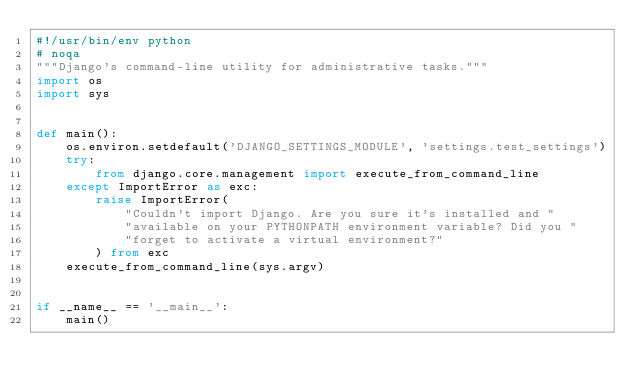Convert code to text. <code><loc_0><loc_0><loc_500><loc_500><_Python_>#!/usr/bin/env python
# noqa
"""Django's command-line utility for administrative tasks."""
import os
import sys


def main():
    os.environ.setdefault('DJANGO_SETTINGS_MODULE', 'settings.test_settings')
    try:
        from django.core.management import execute_from_command_line
    except ImportError as exc:
        raise ImportError(
            "Couldn't import Django. Are you sure it's installed and "
            "available on your PYTHONPATH environment variable? Did you "
            "forget to activate a virtual environment?"
        ) from exc
    execute_from_command_line(sys.argv)


if __name__ == '__main__':
    main()
</code> 